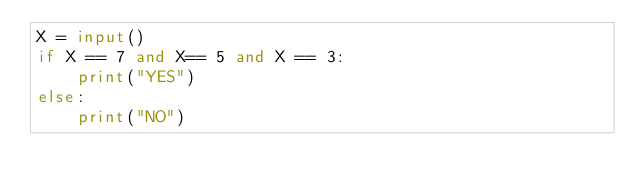Convert code to text. <code><loc_0><loc_0><loc_500><loc_500><_Python_>X = input()
if X == 7 and X== 5 and X == 3:
    print("YES")
else:
    print("NO")</code> 